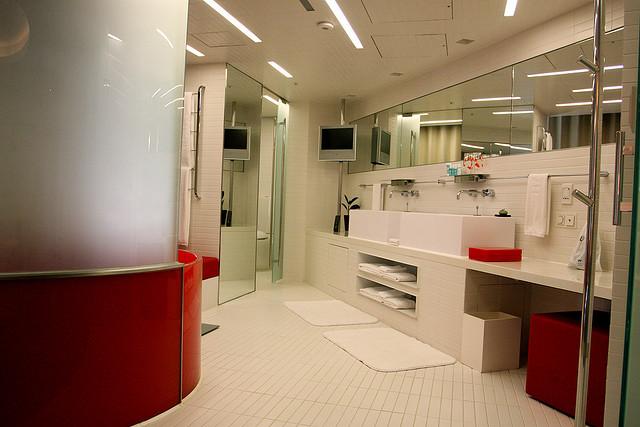What is the main color of the bathroom?
Quick response, please. White. Is this a modern bathroom?
Concise answer only. Yes. What color is the floor?
Quick response, please. White. What color is the floor mat?
Be succinct. White. How many rugs are on the floor?
Concise answer only. 2. 